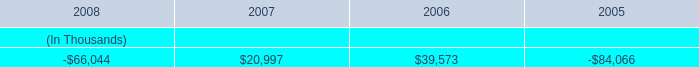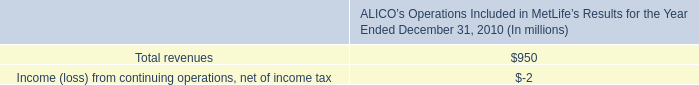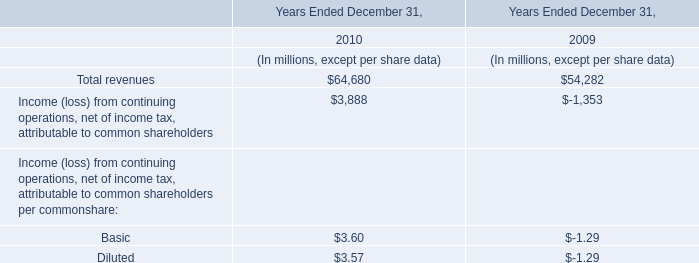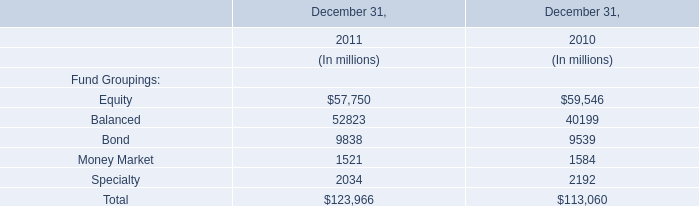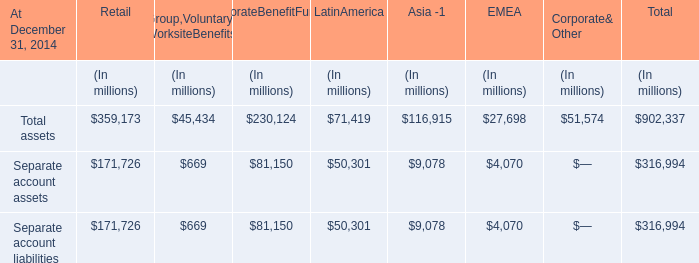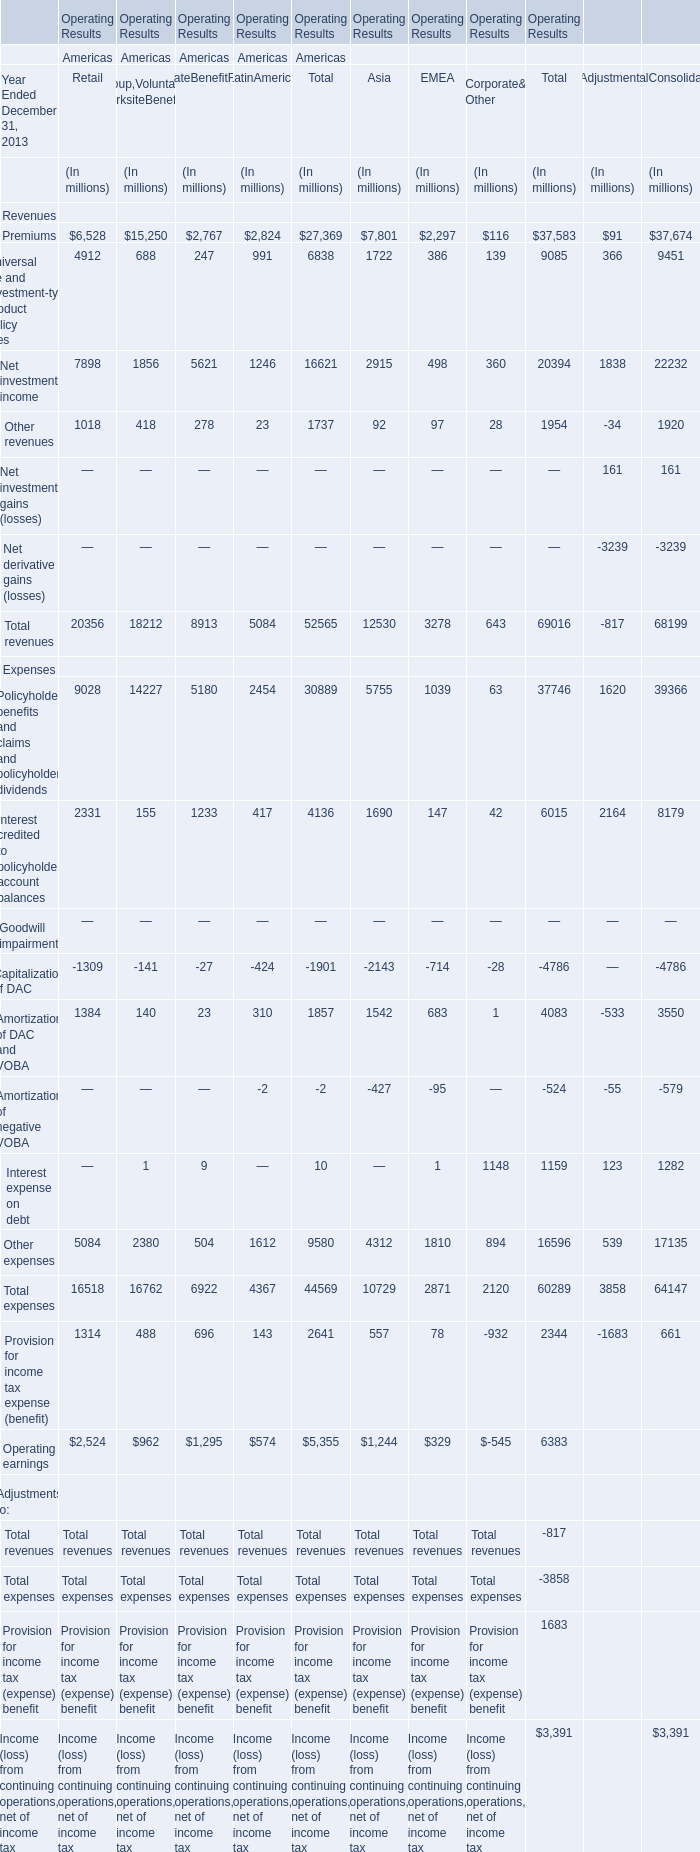In which section the sum of Total assets has the highest value? 
Answer: Retail. 